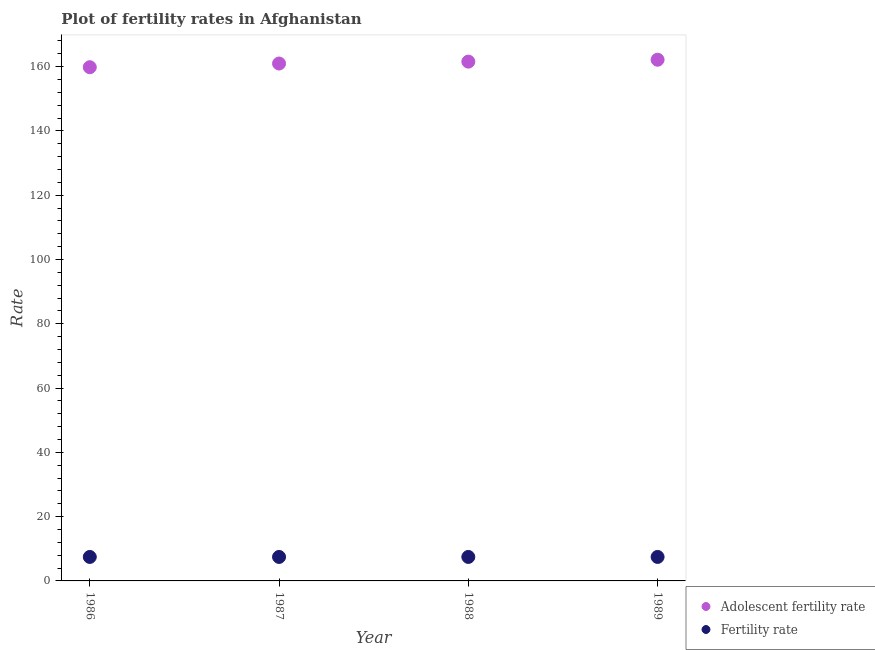What is the fertility rate in 1986?
Offer a very short reply. 7.46. Across all years, what is the maximum fertility rate?
Ensure brevity in your answer.  7.46. Across all years, what is the minimum adolescent fertility rate?
Keep it short and to the point. 159.82. What is the total adolescent fertility rate in the graph?
Provide a succinct answer. 644.5. What is the difference between the adolescent fertility rate in 1986 and that in 1987?
Provide a short and direct response. -1.15. What is the difference between the adolescent fertility rate in 1989 and the fertility rate in 1987?
Offer a very short reply. 154.69. What is the average fertility rate per year?
Give a very brief answer. 7.46. In the year 1988, what is the difference between the fertility rate and adolescent fertility rate?
Make the answer very short. -154.1. In how many years, is the adolescent fertility rate greater than 120?
Offer a terse response. 4. What is the ratio of the adolescent fertility rate in 1986 to that in 1989?
Keep it short and to the point. 0.99. Is the fertility rate in 1987 less than that in 1988?
Provide a succinct answer. No. Is the difference between the adolescent fertility rate in 1986 and 1989 greater than the difference between the fertility rate in 1986 and 1989?
Provide a short and direct response. No. What is the difference between the highest and the lowest adolescent fertility rate?
Keep it short and to the point. 2.33. In how many years, is the fertility rate greater than the average fertility rate taken over all years?
Your response must be concise. 3. What is the difference between two consecutive major ticks on the Y-axis?
Ensure brevity in your answer.  20. Are the values on the major ticks of Y-axis written in scientific E-notation?
Provide a short and direct response. No. Does the graph contain any zero values?
Your response must be concise. No. Where does the legend appear in the graph?
Give a very brief answer. Bottom right. How many legend labels are there?
Give a very brief answer. 2. What is the title of the graph?
Offer a very short reply. Plot of fertility rates in Afghanistan. What is the label or title of the X-axis?
Give a very brief answer. Year. What is the label or title of the Y-axis?
Give a very brief answer. Rate. What is the Rate in Adolescent fertility rate in 1986?
Offer a very short reply. 159.82. What is the Rate in Fertility rate in 1986?
Give a very brief answer. 7.46. What is the Rate in Adolescent fertility rate in 1987?
Keep it short and to the point. 160.97. What is the Rate in Fertility rate in 1987?
Offer a terse response. 7.46. What is the Rate of Adolescent fertility rate in 1988?
Make the answer very short. 161.56. What is the Rate of Fertility rate in 1988?
Your answer should be compact. 7.46. What is the Rate of Adolescent fertility rate in 1989?
Offer a terse response. 162.15. What is the Rate of Fertility rate in 1989?
Your response must be concise. 7.46. Across all years, what is the maximum Rate of Adolescent fertility rate?
Your answer should be very brief. 162.15. Across all years, what is the maximum Rate in Fertility rate?
Keep it short and to the point. 7.46. Across all years, what is the minimum Rate of Adolescent fertility rate?
Provide a succinct answer. 159.82. Across all years, what is the minimum Rate of Fertility rate?
Provide a succinct answer. 7.46. What is the total Rate in Adolescent fertility rate in the graph?
Give a very brief answer. 644.5. What is the total Rate of Fertility rate in the graph?
Your response must be concise. 29.84. What is the difference between the Rate in Adolescent fertility rate in 1986 and that in 1987?
Provide a short and direct response. -1.15. What is the difference between the Rate of Fertility rate in 1986 and that in 1987?
Offer a terse response. -0. What is the difference between the Rate in Adolescent fertility rate in 1986 and that in 1988?
Provide a succinct answer. -1.74. What is the difference between the Rate in Fertility rate in 1986 and that in 1988?
Offer a terse response. -0. What is the difference between the Rate of Adolescent fertility rate in 1986 and that in 1989?
Provide a short and direct response. -2.33. What is the difference between the Rate in Fertility rate in 1986 and that in 1989?
Offer a terse response. -0. What is the difference between the Rate in Adolescent fertility rate in 1987 and that in 1988?
Offer a very short reply. -0.59. What is the difference between the Rate in Adolescent fertility rate in 1987 and that in 1989?
Give a very brief answer. -1.18. What is the difference between the Rate of Fertility rate in 1987 and that in 1989?
Keep it short and to the point. 0. What is the difference between the Rate of Adolescent fertility rate in 1988 and that in 1989?
Your answer should be compact. -0.59. What is the difference between the Rate of Adolescent fertility rate in 1986 and the Rate of Fertility rate in 1987?
Make the answer very short. 152.36. What is the difference between the Rate of Adolescent fertility rate in 1986 and the Rate of Fertility rate in 1988?
Your response must be concise. 152.36. What is the difference between the Rate in Adolescent fertility rate in 1986 and the Rate in Fertility rate in 1989?
Your answer should be very brief. 152.36. What is the difference between the Rate of Adolescent fertility rate in 1987 and the Rate of Fertility rate in 1988?
Provide a succinct answer. 153.51. What is the difference between the Rate of Adolescent fertility rate in 1987 and the Rate of Fertility rate in 1989?
Ensure brevity in your answer.  153.51. What is the difference between the Rate in Adolescent fertility rate in 1988 and the Rate in Fertility rate in 1989?
Offer a very short reply. 154.1. What is the average Rate of Adolescent fertility rate per year?
Make the answer very short. 161.13. What is the average Rate in Fertility rate per year?
Your response must be concise. 7.46. In the year 1986, what is the difference between the Rate in Adolescent fertility rate and Rate in Fertility rate?
Your response must be concise. 152.36. In the year 1987, what is the difference between the Rate of Adolescent fertility rate and Rate of Fertility rate?
Offer a terse response. 153.51. In the year 1988, what is the difference between the Rate of Adolescent fertility rate and Rate of Fertility rate?
Ensure brevity in your answer.  154.1. In the year 1989, what is the difference between the Rate of Adolescent fertility rate and Rate of Fertility rate?
Offer a terse response. 154.69. What is the ratio of the Rate of Adolescent fertility rate in 1986 to that in 1987?
Provide a succinct answer. 0.99. What is the ratio of the Rate of Fertility rate in 1986 to that in 1987?
Your answer should be compact. 1. What is the ratio of the Rate in Adolescent fertility rate in 1986 to that in 1988?
Offer a very short reply. 0.99. What is the ratio of the Rate in Fertility rate in 1986 to that in 1988?
Your answer should be very brief. 1. What is the ratio of the Rate of Adolescent fertility rate in 1986 to that in 1989?
Offer a terse response. 0.99. What is the ratio of the Rate of Adolescent fertility rate in 1987 to that in 1988?
Your answer should be very brief. 1. What is the ratio of the Rate in Adolescent fertility rate in 1987 to that in 1989?
Make the answer very short. 0.99. What is the ratio of the Rate of Adolescent fertility rate in 1988 to that in 1989?
Offer a terse response. 1. What is the ratio of the Rate of Fertility rate in 1988 to that in 1989?
Offer a terse response. 1. What is the difference between the highest and the second highest Rate of Adolescent fertility rate?
Keep it short and to the point. 0.59. What is the difference between the highest and the lowest Rate of Adolescent fertility rate?
Offer a terse response. 2.33. What is the difference between the highest and the lowest Rate in Fertility rate?
Your answer should be very brief. 0. 